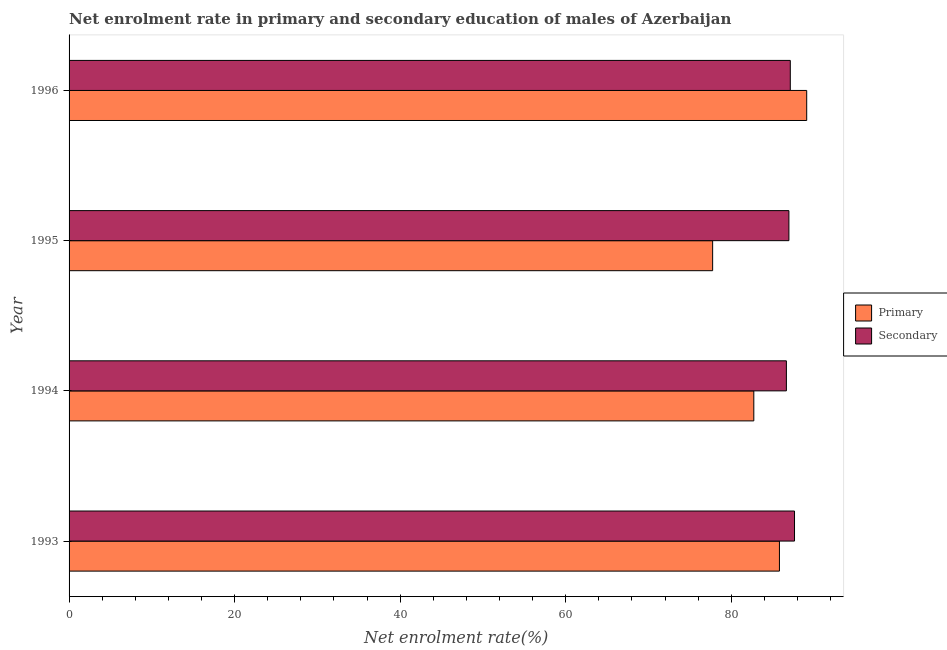How many different coloured bars are there?
Your answer should be very brief. 2. Are the number of bars per tick equal to the number of legend labels?
Your answer should be compact. Yes. How many bars are there on the 3rd tick from the bottom?
Provide a short and direct response. 2. In how many cases, is the number of bars for a given year not equal to the number of legend labels?
Provide a succinct answer. 0. What is the enrollment rate in primary education in 1994?
Offer a very short reply. 82.72. Across all years, what is the maximum enrollment rate in secondary education?
Offer a terse response. 87.64. Across all years, what is the minimum enrollment rate in secondary education?
Provide a short and direct response. 86.65. In which year was the enrollment rate in primary education maximum?
Give a very brief answer. 1996. What is the total enrollment rate in secondary education in the graph?
Make the answer very short. 348.37. What is the difference between the enrollment rate in secondary education in 1995 and that in 1996?
Provide a short and direct response. -0.17. What is the difference between the enrollment rate in secondary education in 1995 and the enrollment rate in primary education in 1996?
Keep it short and to the point. -2.15. What is the average enrollment rate in primary education per year?
Your answer should be compact. 83.84. In the year 1994, what is the difference between the enrollment rate in primary education and enrollment rate in secondary education?
Make the answer very short. -3.94. What is the ratio of the enrollment rate in primary education in 1994 to that in 1995?
Make the answer very short. 1.06. Is the enrollment rate in secondary education in 1993 less than that in 1995?
Offer a terse response. No. What is the difference between the highest and the second highest enrollment rate in secondary education?
Give a very brief answer. 0.51. What is the difference between the highest and the lowest enrollment rate in secondary education?
Give a very brief answer. 0.98. What does the 2nd bar from the top in 1994 represents?
Offer a terse response. Primary. What does the 1st bar from the bottom in 1996 represents?
Ensure brevity in your answer.  Primary. Are all the bars in the graph horizontal?
Give a very brief answer. Yes. How many years are there in the graph?
Provide a short and direct response. 4. What is the difference between two consecutive major ticks on the X-axis?
Ensure brevity in your answer.  20. Are the values on the major ticks of X-axis written in scientific E-notation?
Make the answer very short. No. Does the graph contain any zero values?
Your response must be concise. No. Does the graph contain grids?
Your answer should be very brief. No. How many legend labels are there?
Offer a very short reply. 2. How are the legend labels stacked?
Give a very brief answer. Vertical. What is the title of the graph?
Keep it short and to the point. Net enrolment rate in primary and secondary education of males of Azerbaijan. Does "Working only" appear as one of the legend labels in the graph?
Provide a short and direct response. No. What is the label or title of the X-axis?
Keep it short and to the point. Net enrolment rate(%). What is the Net enrolment rate(%) of Primary in 1993?
Offer a very short reply. 85.81. What is the Net enrolment rate(%) of Secondary in 1993?
Ensure brevity in your answer.  87.64. What is the Net enrolment rate(%) of Primary in 1994?
Give a very brief answer. 82.72. What is the Net enrolment rate(%) in Secondary in 1994?
Keep it short and to the point. 86.65. What is the Net enrolment rate(%) of Primary in 1995?
Give a very brief answer. 77.74. What is the Net enrolment rate(%) in Secondary in 1995?
Give a very brief answer. 86.96. What is the Net enrolment rate(%) of Primary in 1996?
Your response must be concise. 89.11. What is the Net enrolment rate(%) of Secondary in 1996?
Your response must be concise. 87.13. Across all years, what is the maximum Net enrolment rate(%) of Primary?
Keep it short and to the point. 89.11. Across all years, what is the maximum Net enrolment rate(%) in Secondary?
Provide a short and direct response. 87.64. Across all years, what is the minimum Net enrolment rate(%) in Primary?
Ensure brevity in your answer.  77.74. Across all years, what is the minimum Net enrolment rate(%) in Secondary?
Your answer should be compact. 86.65. What is the total Net enrolment rate(%) in Primary in the graph?
Make the answer very short. 335.38. What is the total Net enrolment rate(%) of Secondary in the graph?
Keep it short and to the point. 348.37. What is the difference between the Net enrolment rate(%) in Primary in 1993 and that in 1994?
Keep it short and to the point. 3.1. What is the difference between the Net enrolment rate(%) of Primary in 1993 and that in 1995?
Give a very brief answer. 8.07. What is the difference between the Net enrolment rate(%) in Secondary in 1993 and that in 1995?
Give a very brief answer. 0.68. What is the difference between the Net enrolment rate(%) in Primary in 1993 and that in 1996?
Offer a terse response. -3.29. What is the difference between the Net enrolment rate(%) in Secondary in 1993 and that in 1996?
Your response must be concise. 0.51. What is the difference between the Net enrolment rate(%) in Primary in 1994 and that in 1995?
Offer a terse response. 4.97. What is the difference between the Net enrolment rate(%) in Secondary in 1994 and that in 1995?
Your response must be concise. -0.3. What is the difference between the Net enrolment rate(%) of Primary in 1994 and that in 1996?
Your response must be concise. -6.39. What is the difference between the Net enrolment rate(%) in Secondary in 1994 and that in 1996?
Provide a succinct answer. -0.47. What is the difference between the Net enrolment rate(%) of Primary in 1995 and that in 1996?
Ensure brevity in your answer.  -11.36. What is the difference between the Net enrolment rate(%) in Secondary in 1995 and that in 1996?
Provide a succinct answer. -0.17. What is the difference between the Net enrolment rate(%) of Primary in 1993 and the Net enrolment rate(%) of Secondary in 1994?
Provide a short and direct response. -0.84. What is the difference between the Net enrolment rate(%) of Primary in 1993 and the Net enrolment rate(%) of Secondary in 1995?
Ensure brevity in your answer.  -1.14. What is the difference between the Net enrolment rate(%) of Primary in 1993 and the Net enrolment rate(%) of Secondary in 1996?
Keep it short and to the point. -1.31. What is the difference between the Net enrolment rate(%) in Primary in 1994 and the Net enrolment rate(%) in Secondary in 1995?
Ensure brevity in your answer.  -4.24. What is the difference between the Net enrolment rate(%) in Primary in 1994 and the Net enrolment rate(%) in Secondary in 1996?
Make the answer very short. -4.41. What is the difference between the Net enrolment rate(%) of Primary in 1995 and the Net enrolment rate(%) of Secondary in 1996?
Keep it short and to the point. -9.38. What is the average Net enrolment rate(%) in Primary per year?
Ensure brevity in your answer.  83.85. What is the average Net enrolment rate(%) of Secondary per year?
Give a very brief answer. 87.09. In the year 1993, what is the difference between the Net enrolment rate(%) of Primary and Net enrolment rate(%) of Secondary?
Your answer should be compact. -1.82. In the year 1994, what is the difference between the Net enrolment rate(%) in Primary and Net enrolment rate(%) in Secondary?
Offer a terse response. -3.94. In the year 1995, what is the difference between the Net enrolment rate(%) of Primary and Net enrolment rate(%) of Secondary?
Offer a terse response. -9.21. In the year 1996, what is the difference between the Net enrolment rate(%) in Primary and Net enrolment rate(%) in Secondary?
Your response must be concise. 1.98. What is the ratio of the Net enrolment rate(%) of Primary in 1993 to that in 1994?
Offer a very short reply. 1.04. What is the ratio of the Net enrolment rate(%) of Secondary in 1993 to that in 1994?
Offer a terse response. 1.01. What is the ratio of the Net enrolment rate(%) in Primary in 1993 to that in 1995?
Offer a very short reply. 1.1. What is the ratio of the Net enrolment rate(%) in Primary in 1993 to that in 1996?
Keep it short and to the point. 0.96. What is the ratio of the Net enrolment rate(%) of Secondary in 1993 to that in 1996?
Provide a succinct answer. 1.01. What is the ratio of the Net enrolment rate(%) of Primary in 1994 to that in 1995?
Your response must be concise. 1.06. What is the ratio of the Net enrolment rate(%) of Secondary in 1994 to that in 1995?
Ensure brevity in your answer.  1. What is the ratio of the Net enrolment rate(%) of Primary in 1994 to that in 1996?
Provide a succinct answer. 0.93. What is the ratio of the Net enrolment rate(%) in Secondary in 1994 to that in 1996?
Offer a terse response. 0.99. What is the ratio of the Net enrolment rate(%) of Primary in 1995 to that in 1996?
Make the answer very short. 0.87. What is the difference between the highest and the second highest Net enrolment rate(%) in Primary?
Give a very brief answer. 3.29. What is the difference between the highest and the second highest Net enrolment rate(%) of Secondary?
Offer a very short reply. 0.51. What is the difference between the highest and the lowest Net enrolment rate(%) of Primary?
Your answer should be compact. 11.36. 